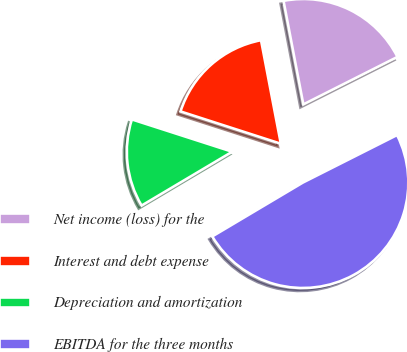Convert chart to OTSL. <chart><loc_0><loc_0><loc_500><loc_500><pie_chart><fcel>Net income (loss) for the<fcel>Interest and debt expense<fcel>Depreciation and amortization<fcel>EBITDA for the three months<nl><fcel>20.57%<fcel>17.03%<fcel>13.49%<fcel>48.9%<nl></chart> 